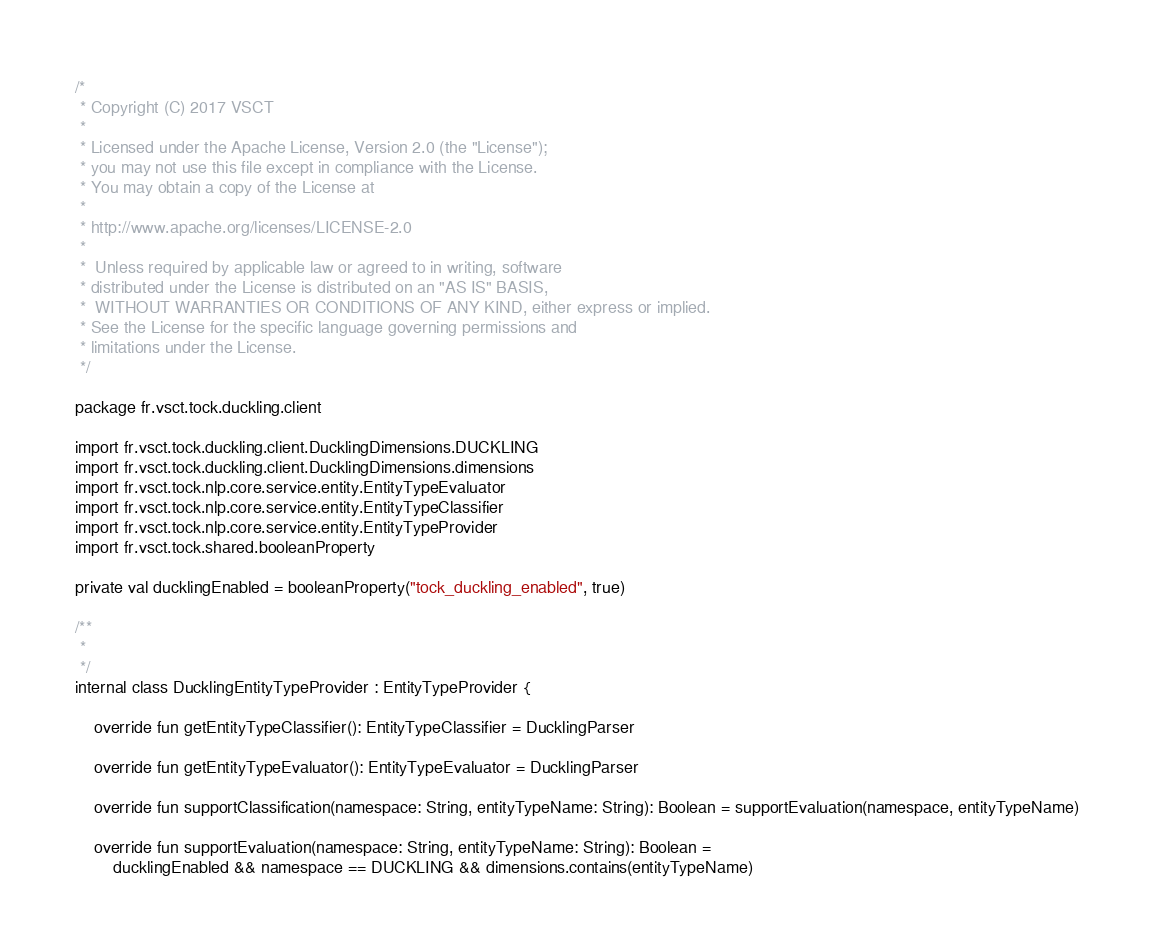<code> <loc_0><loc_0><loc_500><loc_500><_Kotlin_>/*
 * Copyright (C) 2017 VSCT
 *
 * Licensed under the Apache License, Version 2.0 (the "License");
 * you may not use this file except in compliance with the License.
 * You may obtain a copy of the License at
 *
 * http://www.apache.org/licenses/LICENSE-2.0
 *
 *  Unless required by applicable law or agreed to in writing, software
 * distributed under the License is distributed on an "AS IS" BASIS,
 *  WITHOUT WARRANTIES OR CONDITIONS OF ANY KIND, either express or implied.
 * See the License for the specific language governing permissions and
 * limitations under the License.
 */

package fr.vsct.tock.duckling.client

import fr.vsct.tock.duckling.client.DucklingDimensions.DUCKLING
import fr.vsct.tock.duckling.client.DucklingDimensions.dimensions
import fr.vsct.tock.nlp.core.service.entity.EntityTypeEvaluator
import fr.vsct.tock.nlp.core.service.entity.EntityTypeClassifier
import fr.vsct.tock.nlp.core.service.entity.EntityTypeProvider
import fr.vsct.tock.shared.booleanProperty

private val ducklingEnabled = booleanProperty("tock_duckling_enabled", true)

/**
 *
 */
internal class DucklingEntityTypeProvider : EntityTypeProvider {

    override fun getEntityTypeClassifier(): EntityTypeClassifier = DucklingParser

    override fun getEntityTypeEvaluator(): EntityTypeEvaluator = DucklingParser

    override fun supportClassification(namespace: String, entityTypeName: String): Boolean = supportEvaluation(namespace, entityTypeName)

    override fun supportEvaluation(namespace: String, entityTypeName: String): Boolean =
        ducklingEnabled && namespace == DUCKLING && dimensions.contains(entityTypeName)
</code> 